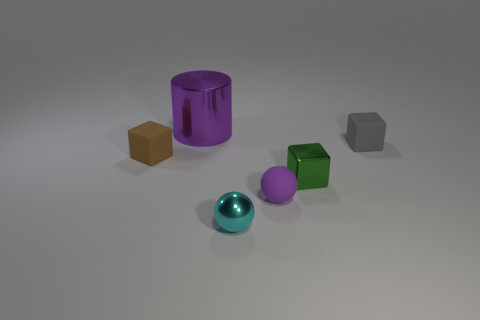Add 4 small brown objects. How many objects exist? 10 Subtract all spheres. How many objects are left? 4 Subtract all purple things. Subtract all rubber spheres. How many objects are left? 3 Add 2 tiny purple things. How many tiny purple things are left? 3 Add 6 small cubes. How many small cubes exist? 9 Subtract 0 blue blocks. How many objects are left? 6 